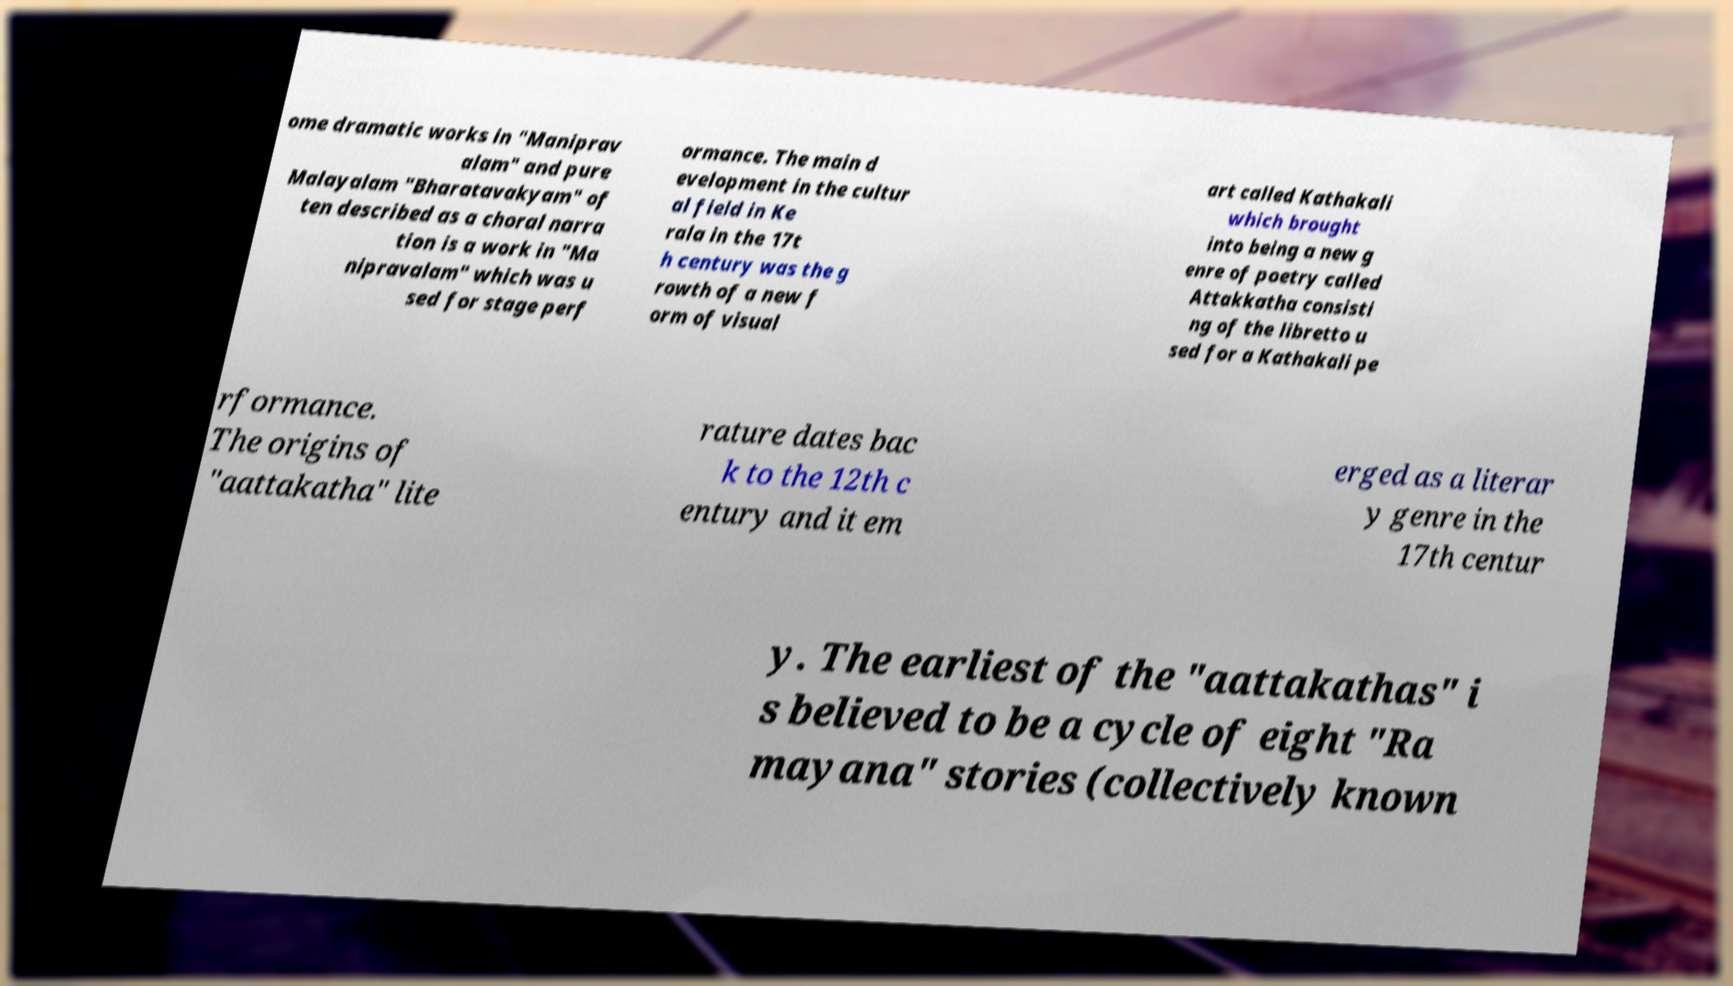Can you read and provide the text displayed in the image?This photo seems to have some interesting text. Can you extract and type it out for me? ome dramatic works in "Maniprav alam" and pure Malayalam "Bharatavakyam" of ten described as a choral narra tion is a work in "Ma nipravalam" which was u sed for stage perf ormance. The main d evelopment in the cultur al field in Ke rala in the 17t h century was the g rowth of a new f orm of visual art called Kathakali which brought into being a new g enre of poetry called Attakkatha consisti ng of the libretto u sed for a Kathakali pe rformance. The origins of "aattakatha" lite rature dates bac k to the 12th c entury and it em erged as a literar y genre in the 17th centur y. The earliest of the "aattakathas" i s believed to be a cycle of eight "Ra mayana" stories (collectively known 